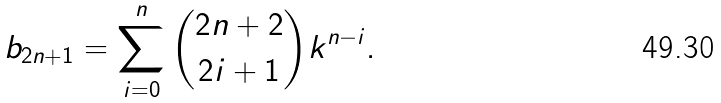<formula> <loc_0><loc_0><loc_500><loc_500>b _ { 2 n + 1 } = \sum _ { i = 0 } ^ { n } { 2 n + 2 \choose 2 i + 1 } k ^ { n - i } .</formula> 